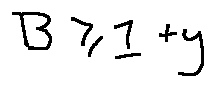<formula> <loc_0><loc_0><loc_500><loc_500>B \geq 1 + y</formula> 